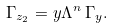Convert formula to latex. <formula><loc_0><loc_0><loc_500><loc_500>\Gamma _ { z _ { 2 } } = y \Lambda ^ { n } \, \Gamma _ { y } .</formula> 